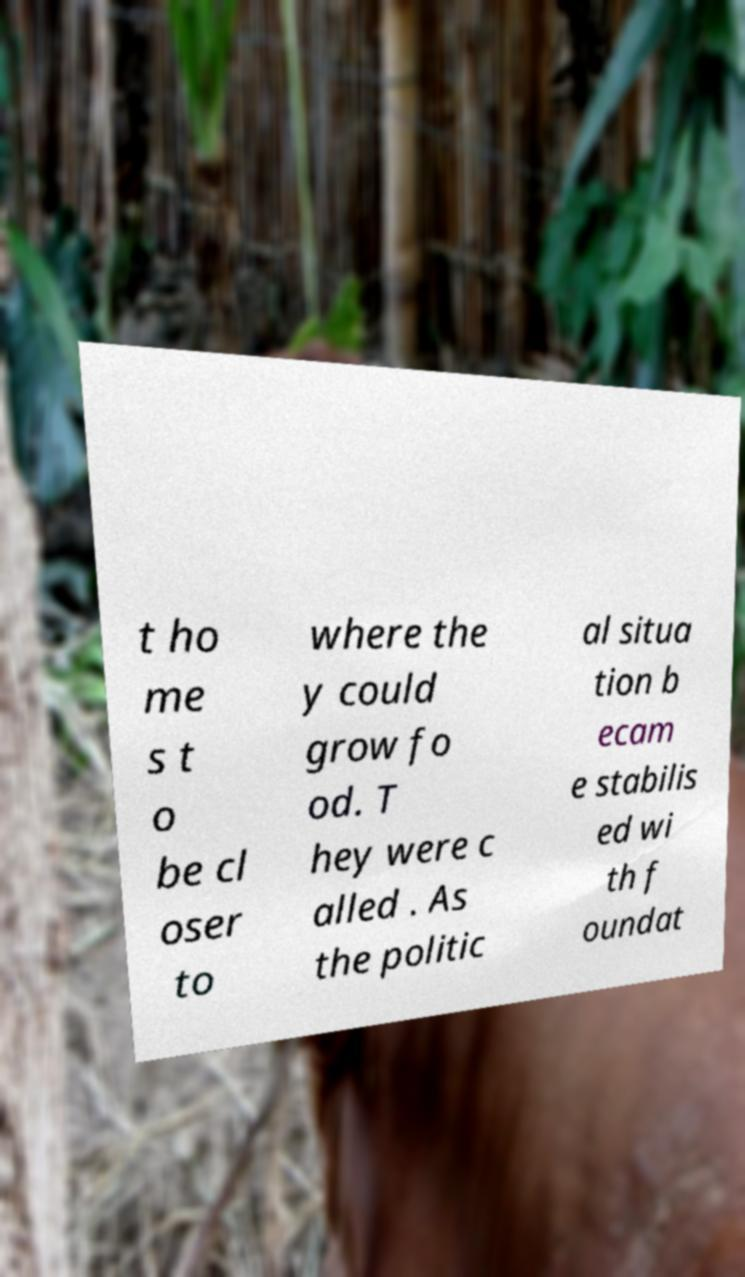Can you read and provide the text displayed in the image?This photo seems to have some interesting text. Can you extract and type it out for me? t ho me s t o be cl oser to where the y could grow fo od. T hey were c alled . As the politic al situa tion b ecam e stabilis ed wi th f oundat 